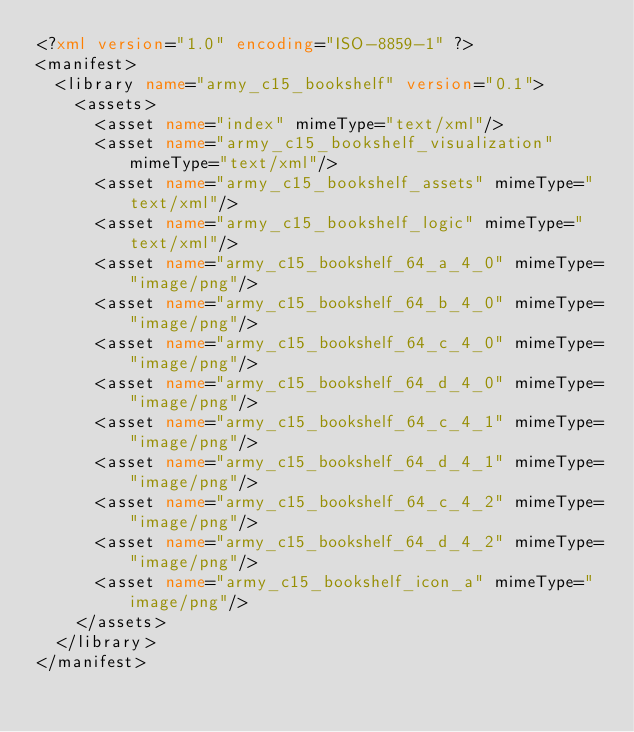<code> <loc_0><loc_0><loc_500><loc_500><_XML_><?xml version="1.0" encoding="ISO-8859-1" ?><manifest>
  <library name="army_c15_bookshelf" version="0.1">
    <assets>
      <asset name="index" mimeType="text/xml"/>
      <asset name="army_c15_bookshelf_visualization" mimeType="text/xml"/>
      <asset name="army_c15_bookshelf_assets" mimeType="text/xml"/>
      <asset name="army_c15_bookshelf_logic" mimeType="text/xml"/>
      <asset name="army_c15_bookshelf_64_a_4_0" mimeType="image/png"/>
      <asset name="army_c15_bookshelf_64_b_4_0" mimeType="image/png"/>
      <asset name="army_c15_bookshelf_64_c_4_0" mimeType="image/png"/>
      <asset name="army_c15_bookshelf_64_d_4_0" mimeType="image/png"/>
      <asset name="army_c15_bookshelf_64_c_4_1" mimeType="image/png"/>
      <asset name="army_c15_bookshelf_64_d_4_1" mimeType="image/png"/>
      <asset name="army_c15_bookshelf_64_c_4_2" mimeType="image/png"/>
      <asset name="army_c15_bookshelf_64_d_4_2" mimeType="image/png"/>
      <asset name="army_c15_bookshelf_icon_a" mimeType="image/png"/>
    </assets>
  </library>
</manifest></code> 